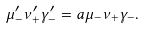<formula> <loc_0><loc_0><loc_500><loc_500>\mu _ { - } ^ { \prime } \nu _ { + } ^ { \prime } \gamma _ { - } ^ { \prime } = a \mu _ { - } \nu _ { + } \gamma _ { - } .</formula> 